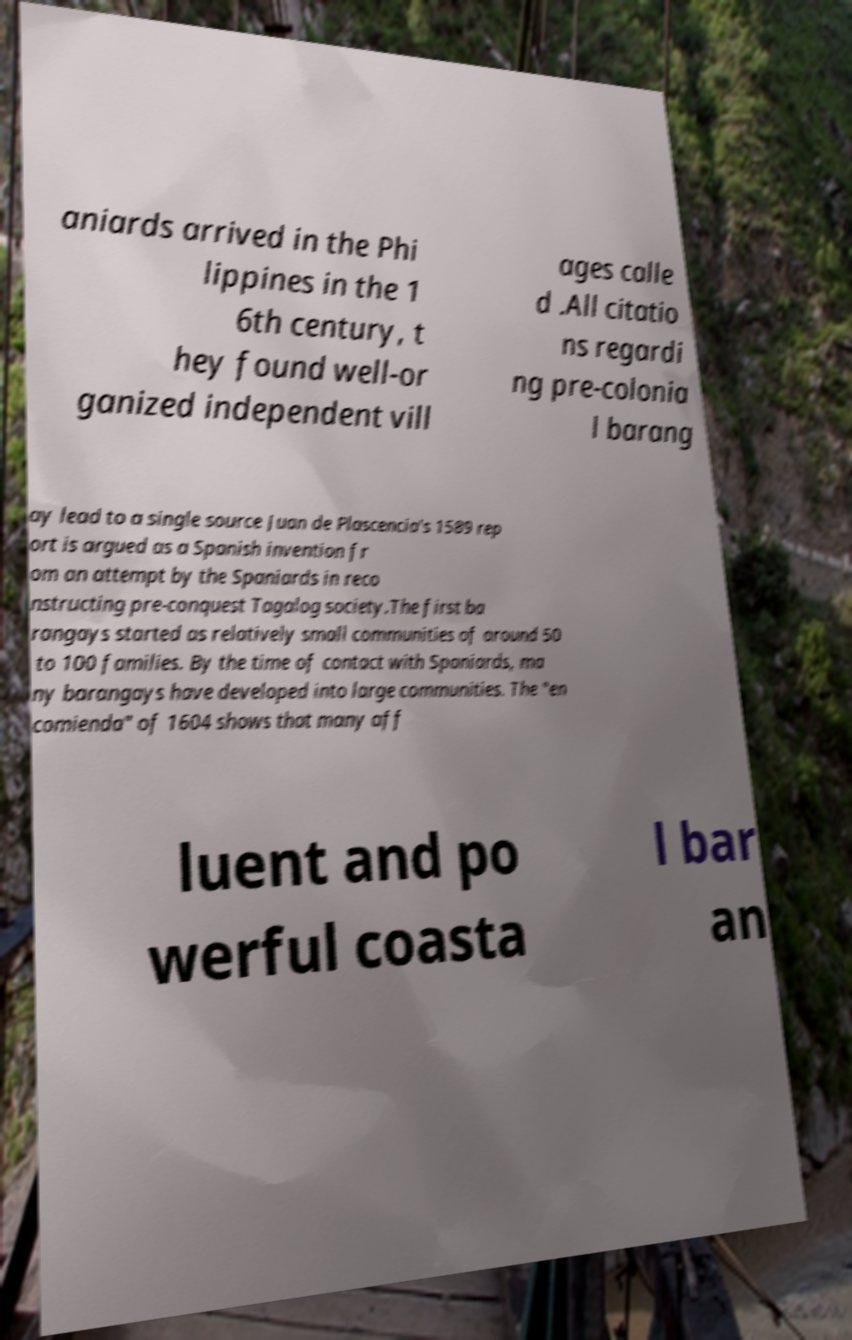There's text embedded in this image that I need extracted. Can you transcribe it verbatim? aniards arrived in the Phi lippines in the 1 6th century, t hey found well-or ganized independent vill ages calle d .All citatio ns regardi ng pre-colonia l barang ay lead to a single source Juan de Plascencia's 1589 rep ort is argued as a Spanish invention fr om an attempt by the Spaniards in reco nstructing pre-conquest Tagalog society.The first ba rangays started as relatively small communities of around 50 to 100 families. By the time of contact with Spaniards, ma ny barangays have developed into large communities. The "en comienda" of 1604 shows that many aff luent and po werful coasta l bar an 